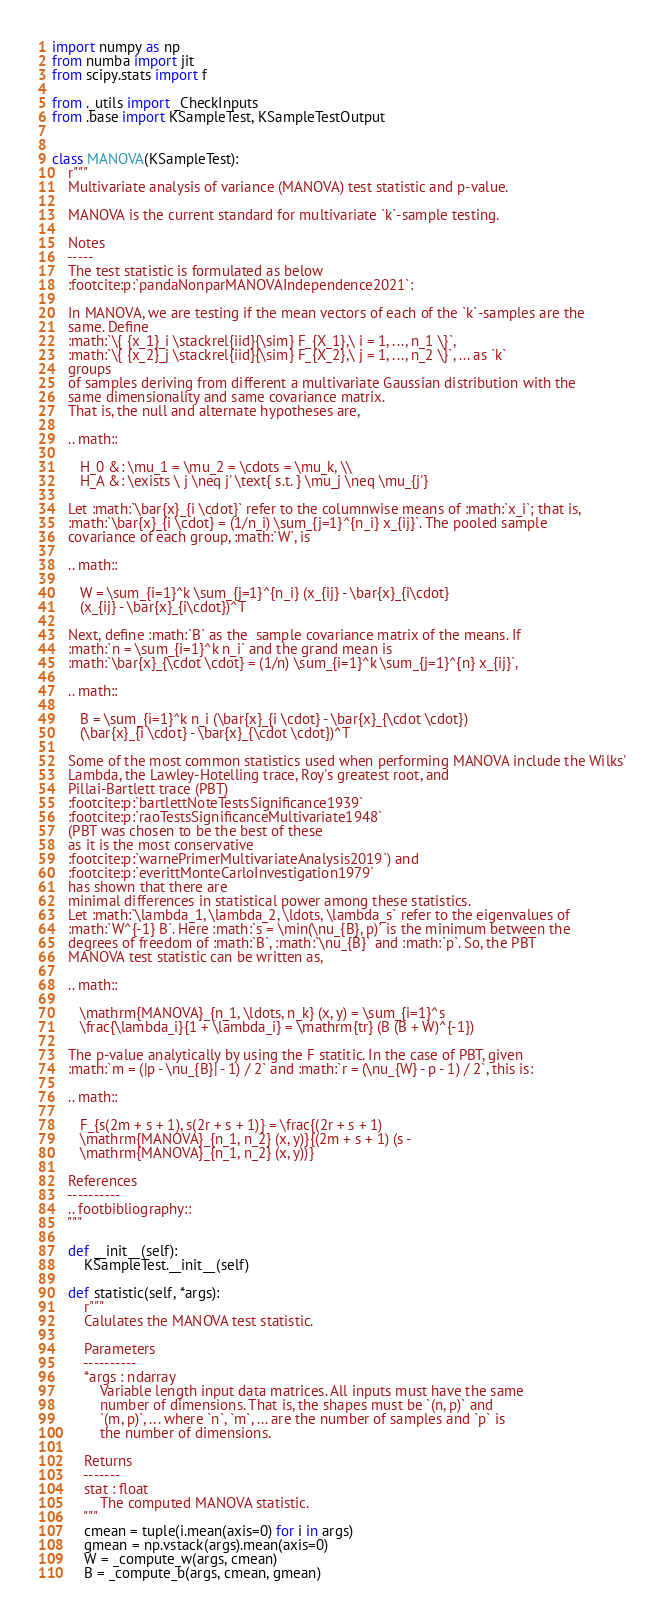Convert code to text. <code><loc_0><loc_0><loc_500><loc_500><_Python_>import numpy as np
from numba import jit
from scipy.stats import f

from ._utils import _CheckInputs
from .base import KSampleTest, KSampleTestOutput


class MANOVA(KSampleTest):
    r"""
    Multivariate analysis of variance (MANOVA) test statistic and p-value.

    MANOVA is the current standard for multivariate `k`-sample testing.

    Notes
    -----
    The test statistic is formulated as below
    :footcite:p:`pandaNonparMANOVAIndependence2021`:

    In MANOVA, we are testing if the mean vectors of each of the `k`-samples are the
    same. Define
    :math:`\{ {x_1}_i \stackrel{iid}{\sim} F_{X_1},\ i = 1, ..., n_1 \}`,
    :math:`\{ {x_2}_j \stackrel{iid}{\sim} F_{X_2},\ j = 1, ..., n_2 \}`, ... as `k`
    groups
    of samples deriving from different a multivariate Gaussian distribution with the
    same dimensionality and same covariance matrix.
    That is, the null and alternate hypotheses are,

    .. math::

       H_0 &: \mu_1 = \mu_2 = \cdots = \mu_k, \\
       H_A &: \exists \ j \neq j' \text{ s.t. } \mu_j \neq \mu_{j'}

    Let :math:`\bar{x}_{i \cdot}` refer to the columnwise means of :math:`x_i`; that is,
    :math:`\bar{x}_{i \cdot} = (1/n_i) \sum_{j=1}^{n_i} x_{ij}`. The pooled sample
    covariance of each group, :math:`W`, is

    .. math::

       W = \sum_{i=1}^k \sum_{j=1}^{n_i} (x_{ij} - \bar{x}_{i\cdot}
       (x_{ij} - \bar{x}_{i\cdot})^T

    Next, define :math:`B` as the  sample covariance matrix of the means. If
    :math:`n = \sum_{i=1}^k n_i` and the grand mean is
    :math:`\bar{x}_{\cdot \cdot} = (1/n) \sum_{i=1}^k \sum_{j=1}^{n} x_{ij}`,

    .. math::

       B = \sum_{i=1}^k n_i (\bar{x}_{i \cdot} - \bar{x}_{\cdot \cdot})
       (\bar{x}_{i \cdot} - \bar{x}_{\cdot \cdot})^T

    Some of the most common statistics used when performing MANOVA include the Wilks'
    Lambda, the Lawley-Hotelling trace, Roy's greatest root, and
    Pillai-Bartlett trace (PBT)
    :footcite:p:`bartlettNoteTestsSignificance1939`
    :footcite:p:`raoTestsSignificanceMultivariate1948`
    (PBT was chosen to be the best of these
    as it is the most conservative
    :footcite:p:`warnePrimerMultivariateAnalysis2019`) and
    :footcite:p:`everittMonteCarloInvestigation1979`
    has shown that there are
    minimal differences in statistical power among these statistics.
    Let :math:`\lambda_1, \lambda_2, \ldots, \lambda_s` refer to the eigenvalues of
    :math:`W^{-1} B`. Here :math:`s = \min(\nu_{B}, p)` is the minimum between the
    degrees of freedom of :math:`B`, :math:`\nu_{B}` and :math:`p`. So, the PBT
    MANOVA test statistic can be written as,

    .. math::

       \mathrm{MANOVA}_{n_1, \ldots, n_k} (x, y) = \sum_{i=1}^s
       \frac{\lambda_i}{1 + \lambda_i} = \mathrm{tr} (B (B + W)^{-1})

    The p-value analytically by using the F statitic. In the case of PBT, given
    :math:`m = (|p - \nu_{B}| - 1) / 2` and :math:`r = (\nu_{W} - p - 1) / 2`, this is:

    .. math::

       F_{s(2m + s + 1), s(2r + s + 1)} = \frac{(2r + s + 1)
       \mathrm{MANOVA}_{n_1, n_2} (x, y)}{(2m + s + 1) (s -
       \mathrm{MANOVA}_{n_1, n_2} (x, y))}

    References
    ----------
    .. footbibliography::
    """

    def __init__(self):
        KSampleTest.__init__(self)

    def statistic(self, *args):
        r"""
        Calulates the MANOVA test statistic.

        Parameters
        ----------
        *args : ndarray
            Variable length input data matrices. All inputs must have the same
            number of dimensions. That is, the shapes must be `(n, p)` and
            `(m, p)`, ... where `n`, `m`, ... are the number of samples and `p` is
            the number of dimensions.

        Returns
        -------
        stat : float
            The computed MANOVA statistic.
        """
        cmean = tuple(i.mean(axis=0) for i in args)
        gmean = np.vstack(args).mean(axis=0)
        W = _compute_w(args, cmean)
        B = _compute_b(args, cmean, gmean)
</code> 